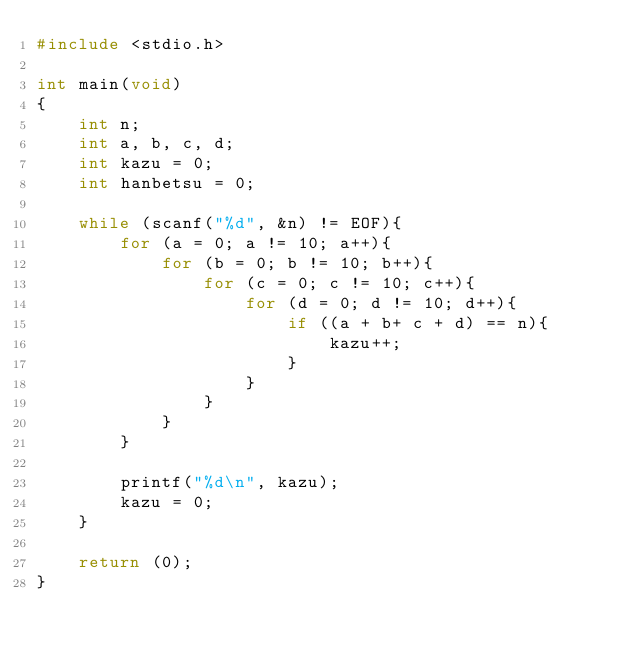<code> <loc_0><loc_0><loc_500><loc_500><_C_>#include <stdio.h>

int main(void)
{
	int n;
	int a, b, c, d;
	int kazu = 0;
	int hanbetsu = 0;
	
	while (scanf("%d", &n) != EOF){
		for (a = 0; a != 10; a++){
			for (b = 0; b != 10; b++){
				for (c = 0; c != 10; c++){
					for (d = 0; d != 10; d++){
						if ((a + b+ c + d) == n){
							kazu++;
						}
					}
				}
			}
		}
		
		printf("%d\n", kazu);
		kazu = 0;
	}
	
	return (0);
}</code> 